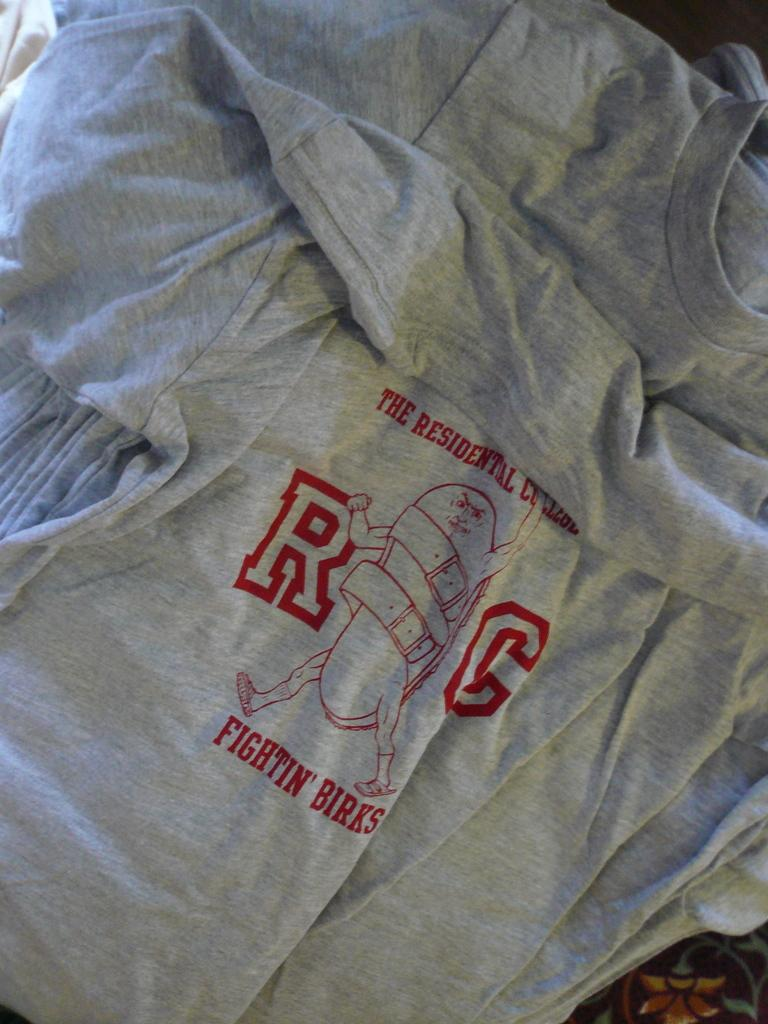<image>
Relay a brief, clear account of the picture shown. A grey shirt that reads The Residential College Fightin' Birks. 